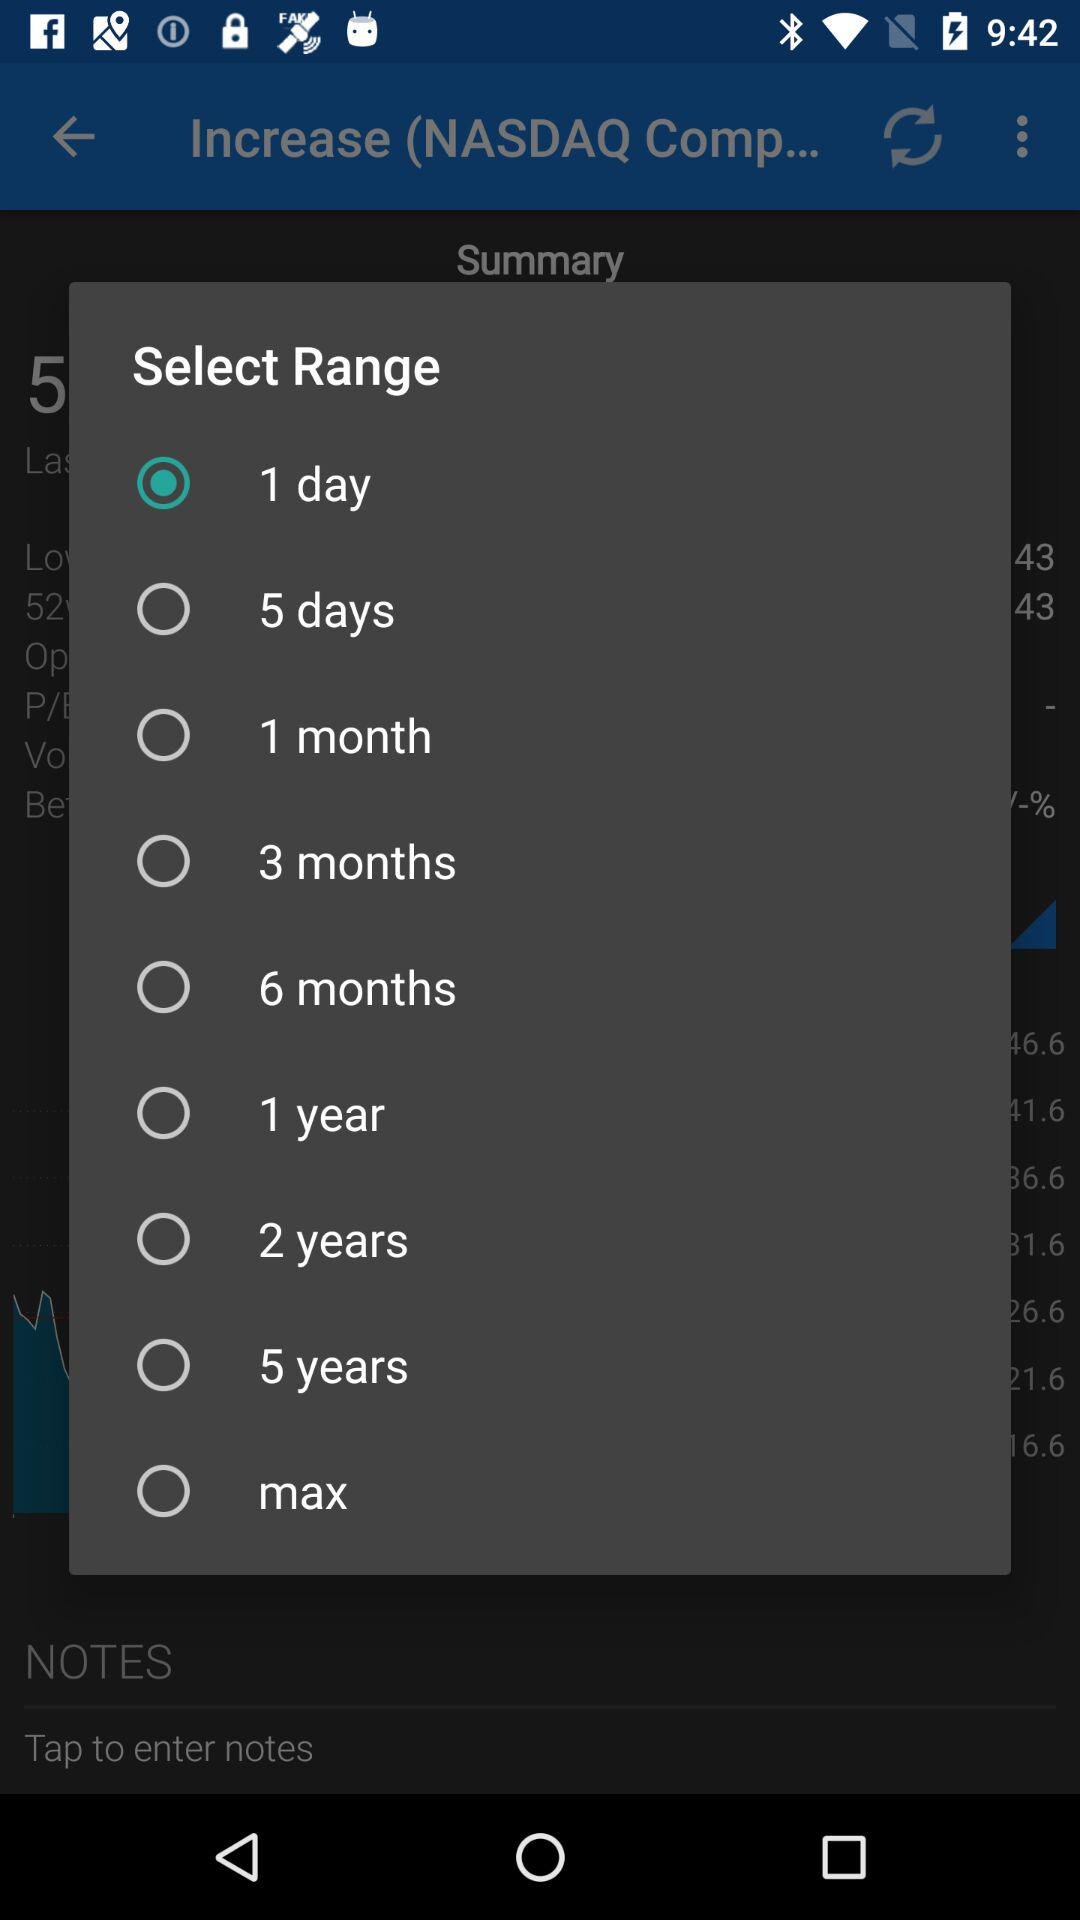Which option is selected? The selected option is "1 day". 